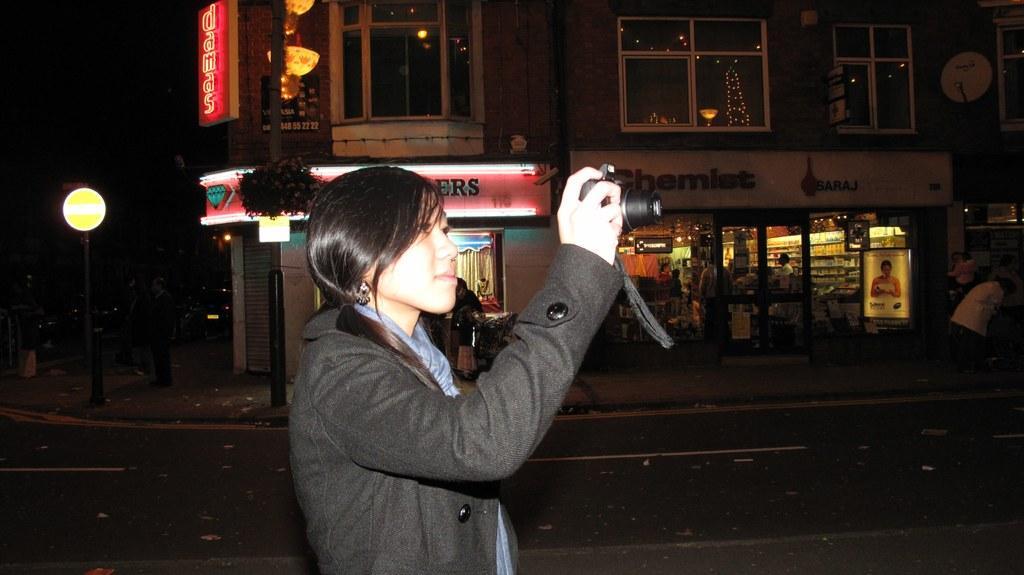How would you summarize this image in a sentence or two? In this image there is a woman standing towards the bottom of the image, she is holding an object, there is road towards the bottom of the image, there is a building towards the top of the image, there are windows, there are boards on the building, there is text on the boards, there is a glass door, there are glass walls, there is a pole, there is a light, there are persons standing, the background of the image is dark. 